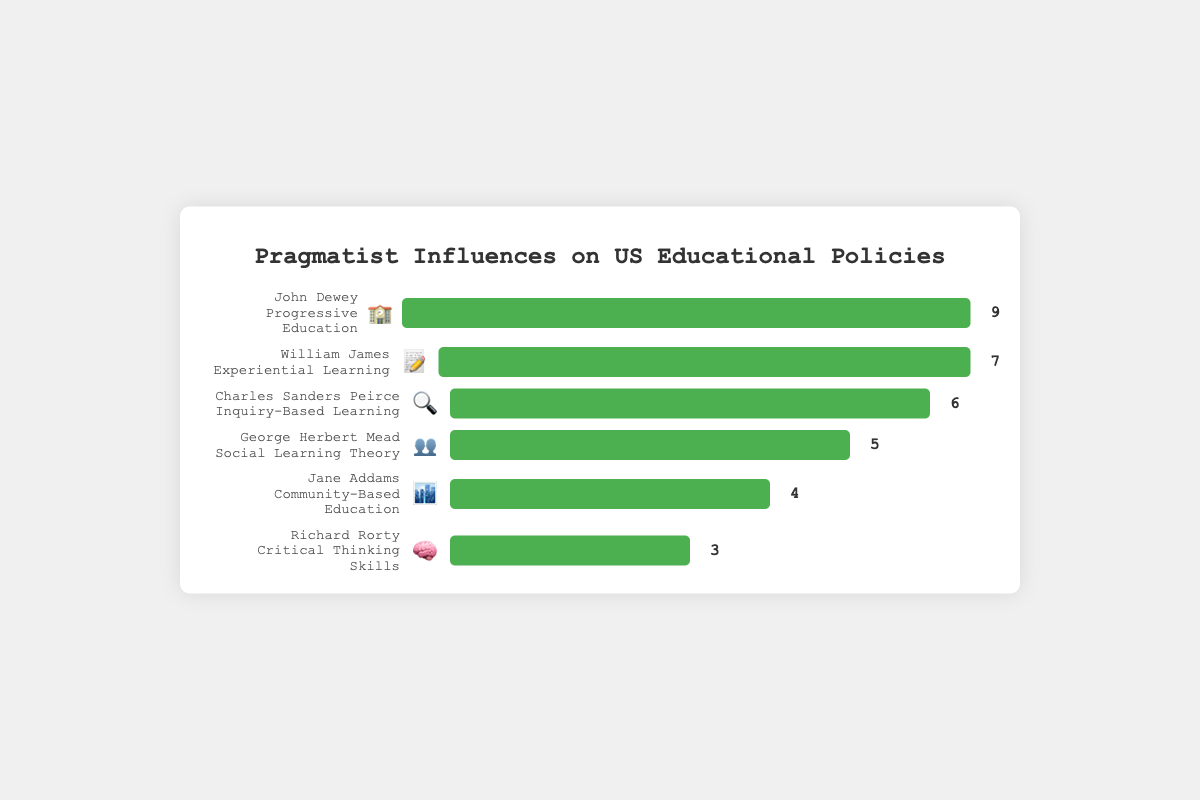Which philosopher and educational policy has the highest impact score? From the figure, John Dewey related to Progressive Education has the widest bar fill, indicating the highest score. The impact score next to his bar shows 9.
Answer: John Dewey, Progressive Education Which emoji is associated with William James and what is his impact score? Looking at William James' bar, the associated emoji is 📝, and the impact score next to his bar is 7.
Answer: 📝, 7 What is the total impact score for Charles Sanders Peirce and Jane Addams combined? Charles Sanders Peirce has an impact score of 6, and Jane Addams has an impact score of 4. Adding these together gives 6 + 4 = 10.
Answer: 10 Which philosopher’s impact comes closest to being 5 points? George Herbert Mead’s bar corresponds to an impact score of 5, making his impact exactly 5.
Answer: George Herbert Mead How much higher is John Dewey's impact score compared to Richard Rorty's? John Dewey’s impact score is 9, while Richard Rorty’s is 3. The difference is 9 - 3 = 6.
Answer: 6 List the philosophers in descending order of their impact scores. By viewing the lengths of the bars and their impact scores: John Dewey (9), William James (7), Charles Sanders Peirce (6), George Herbert Mead (5), Jane Addams (4), Richard Rorty (3).
Answer: John Dewey, William James, Charles Sanders Peirce, George Herbert Mead, Jane Addams, Richard Rorty Which philosopher is associated with the social learning theory, and what is their impact score? George Herbert Mead is connected to the Social Learning Theory as seen from his bar, which has an impact score of 5.
Answer: George Herbert Mead, 5 What's the average impact score of all the philosophers listed? Sum of all scores: 9 + 7 + 6 + 5 + 4 + 3 = 34. Number of philosophers: 6. The average is 34 / 6 ≈ 5.67.
Answer: 5.67 